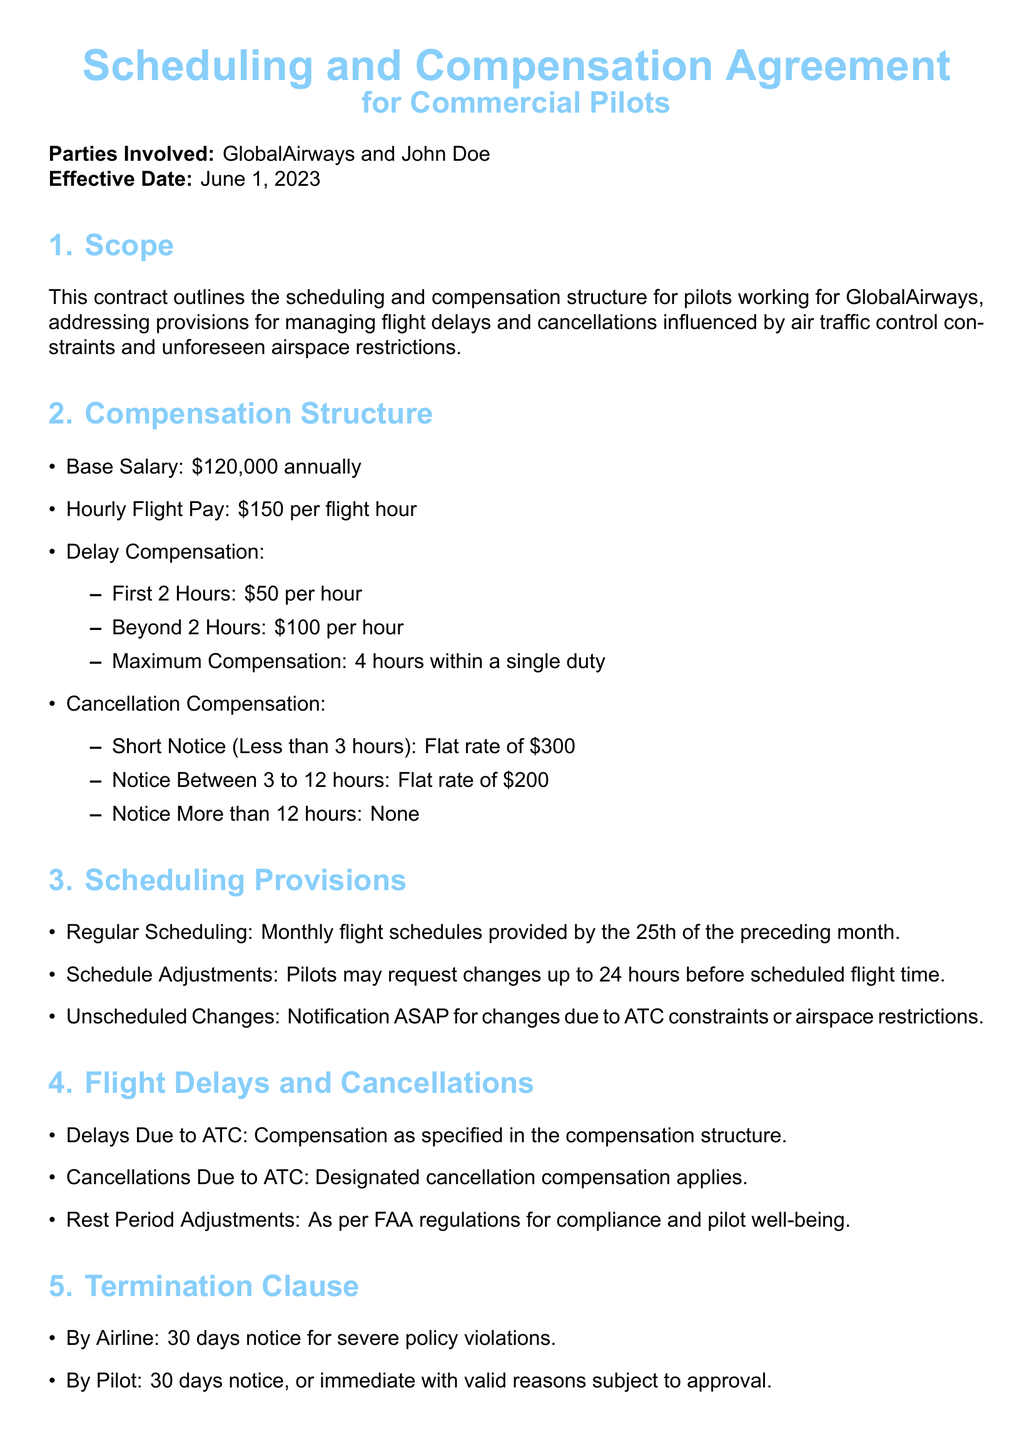What is the effective date of the contract? The effective date is stated at the beginning of the document as June 1, 2023.
Answer: June 1, 2023 What is the base salary for pilots? The base salary is specified in the compensation structure section as $120,000 annually.
Answer: $120,000 annually How much is the hourly flight pay? The document indicates that the hourly flight pay is $150 per flight hour.
Answer: $150 per flight hour What is the maximum delay compensation within a single duty? The maximum compensation for delays is detailed in the compensation structure and is specified as 4 hours.
Answer: 4 hours What is the cancellation compensation for short notice (less than 3 hours)? The document describes that the cancellation compensation for short notice is a flat rate of $300.
Answer: $300 What are the notice conditions for a cancellation with no compensation? The document states that no compensation is provided for cancellations with more than 12 hours notice.
Answer: More than 12 hours What is required for schedule adjustments? According to the scheduling provisions, pilots may request changes up to 24 hours before scheduled flight time.
Answer: 24 hours What is the initial step for dispute resolution outlined in the contract? The document specifies that the first step in dispute resolution is mediation.
Answer: Mediation How long is the notice period required for termination by the airline? The termination clause indicates that 30 days notice is required for termination by the airline.
Answer: 30 days 